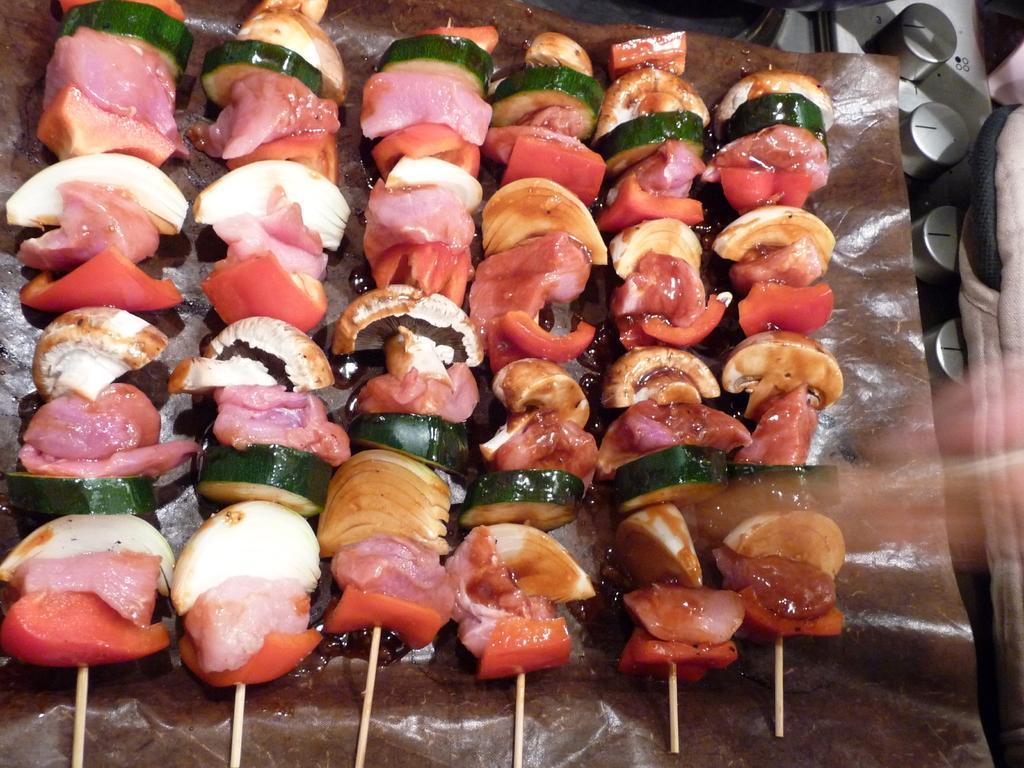Please provide a concise description of this image. In this image I can see there are vegetable pieces attached to the small sticks kept on tray , on the right side there are bottles caps visible 